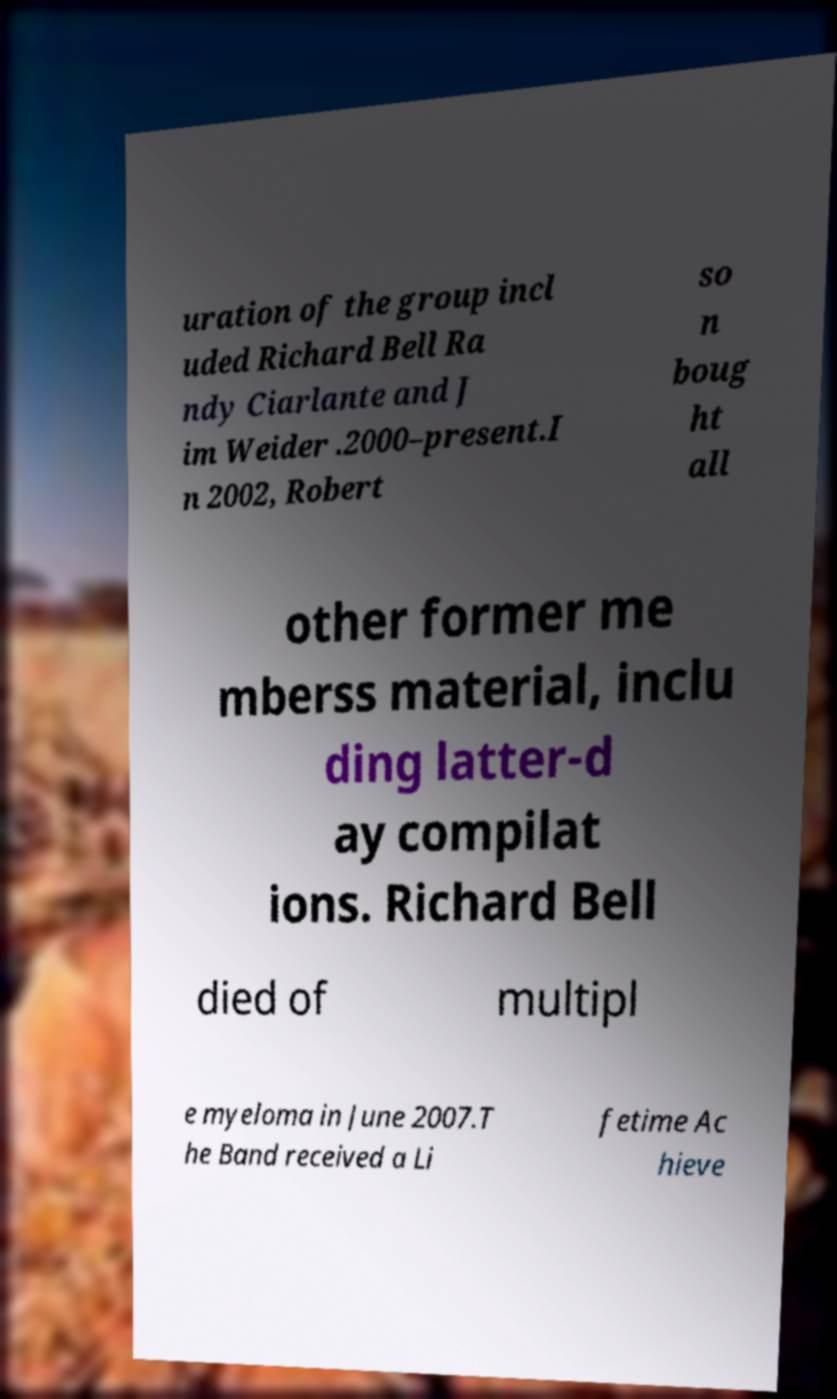Can you accurately transcribe the text from the provided image for me? uration of the group incl uded Richard Bell Ra ndy Ciarlante and J im Weider .2000–present.I n 2002, Robert so n boug ht all other former me mberss material, inclu ding latter-d ay compilat ions. Richard Bell died of multipl e myeloma in June 2007.T he Band received a Li fetime Ac hieve 